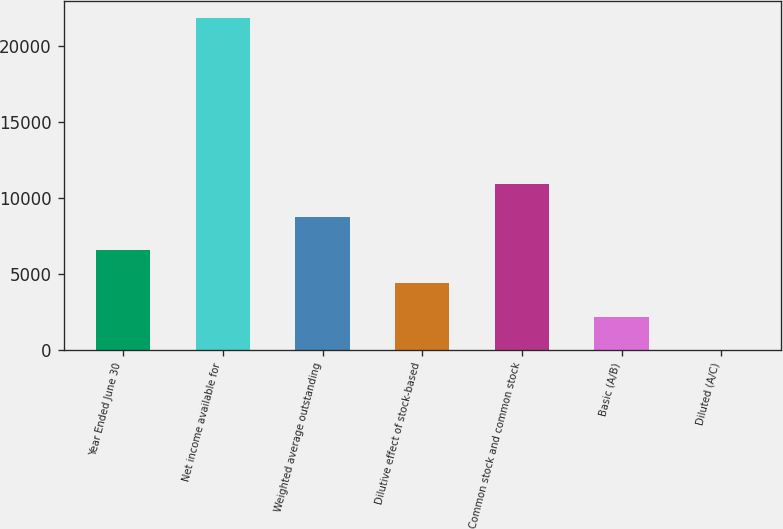Convert chart to OTSL. <chart><loc_0><loc_0><loc_500><loc_500><bar_chart><fcel>Year Ended June 30<fcel>Net income available for<fcel>Weighted average outstanding<fcel>Dilutive effect of stock-based<fcel>Common stock and common stock<fcel>Basic (A/B)<fcel>Diluted (A/C)<nl><fcel>6560.7<fcel>21863<fcel>8746.74<fcel>4374.66<fcel>10932.8<fcel>2188.62<fcel>2.58<nl></chart> 